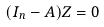<formula> <loc_0><loc_0><loc_500><loc_500>( I _ { n } - A ) Z = 0</formula> 